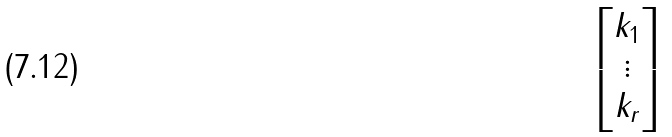Convert formula to latex. <formula><loc_0><loc_0><loc_500><loc_500>\begin{bmatrix} k _ { 1 } \\ \vdots \\ k _ { r } \end{bmatrix}</formula> 